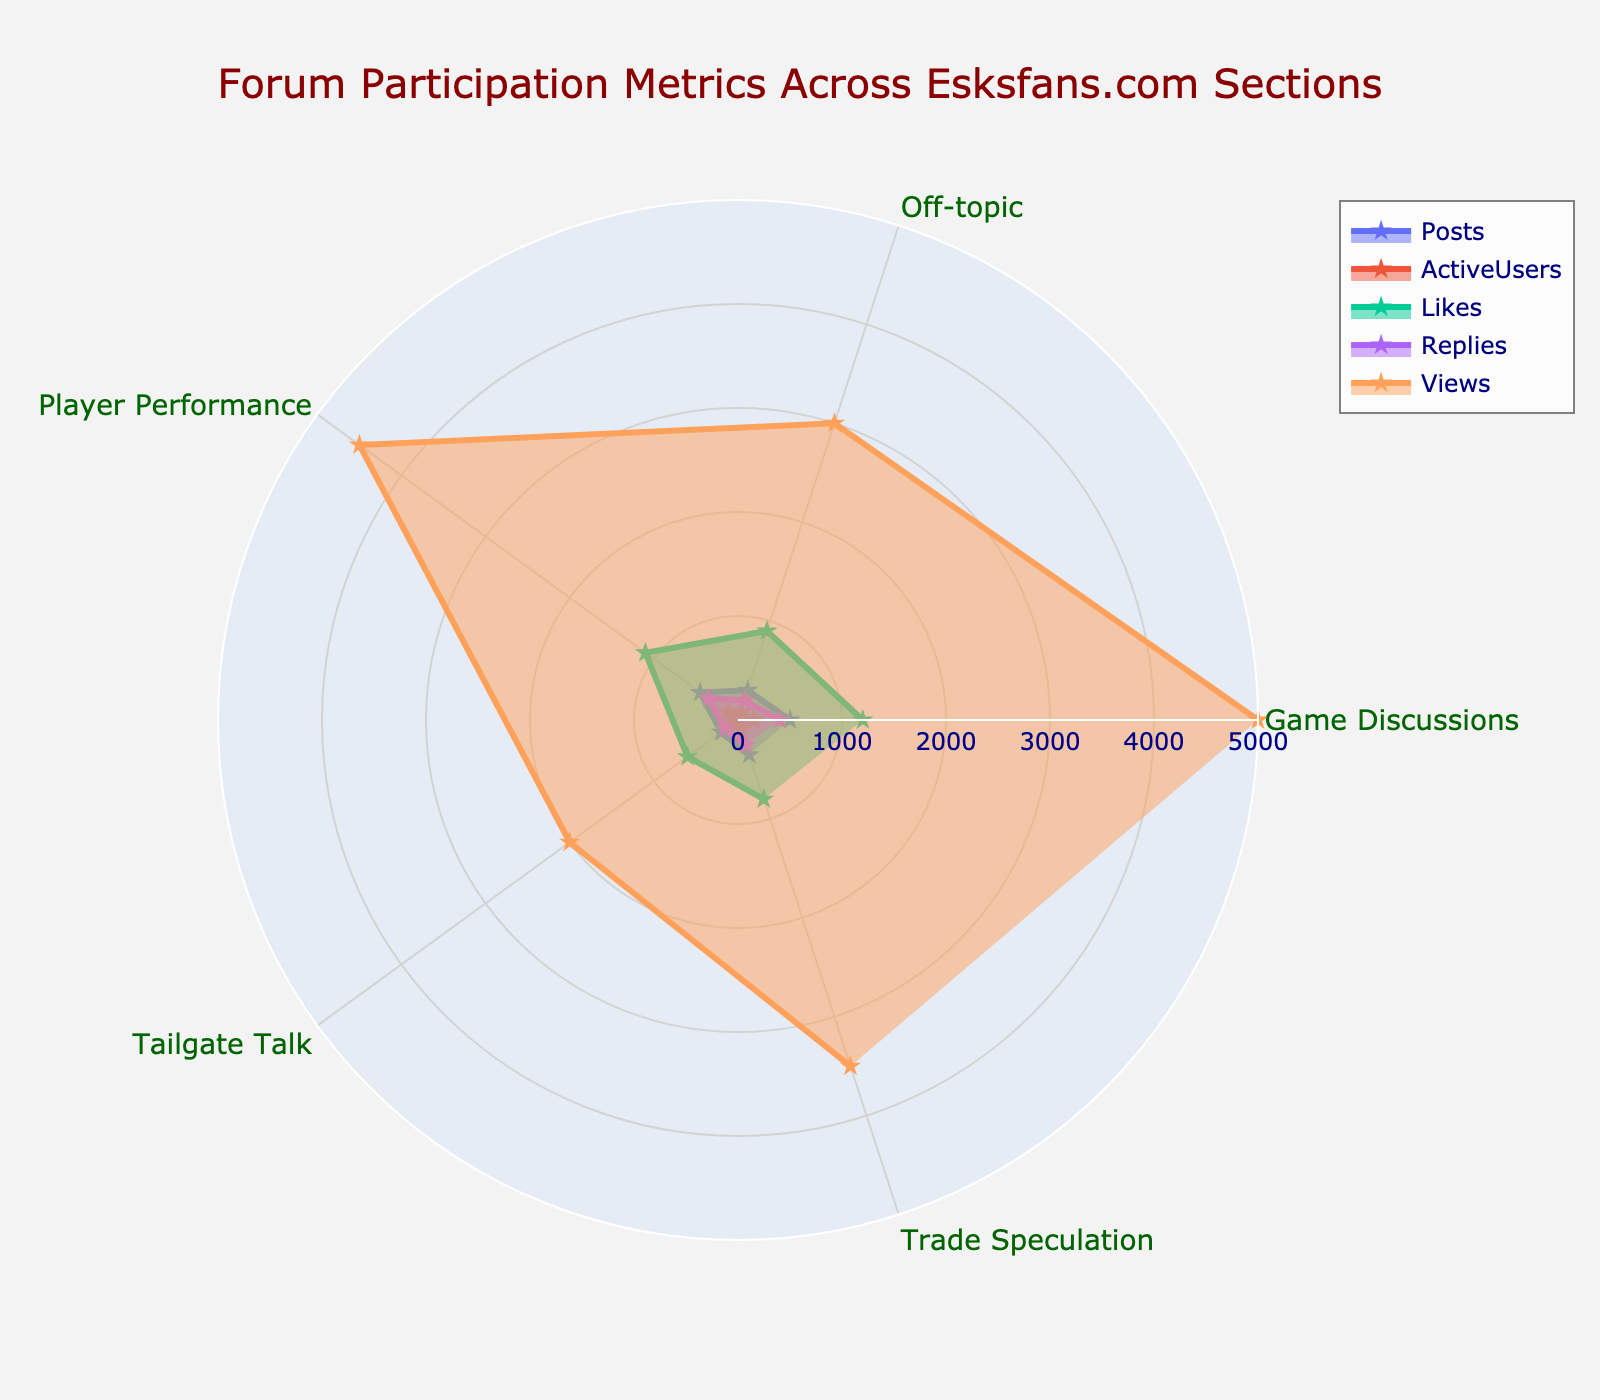what is the section with the highest number of posts?, why is this number high, and why is it important? The radar chart shows the number of posts for each section. The Game Discussions section has the highest number of posts, which indicates a high level of engagement from users who are actively discussing game-related topics. This is important because it suggests that game discussions are the most popular area, potentially driving the most traffic to the forum.
Answer: Game Discussions Which section has the least number of active users? By looking at the radar chart where each section's number of active users is plotted, Tailgate Talk shows the lowest number of active users.
Answer: Tailgate Talk Overall, which metric shows the greatest spread among the sections? To determine the greatest spread, we look for the metric with the widest variation between its minimum and maximum values across all sections. On the radar chart, the metric for Views has the greatest spread, ranging from 2000 to 5000, which illustrates that viewing activity significantly varies by section.
Answer: Views What section features the highest amount of Likes and what does this tell us about user engagement? The radar chart illustrates that Game Discussions has the highest amount of Likes. This high number of likes indicates strong user engagement and suggests that the discussions in this section are highly appreciated or found very informative by community members.
Answer: Game Discussions Compare the number of replies in Game Discussions and Player Performance. In which section is there more interaction and by how much? By comparing the radar chart data, we see that Game Discussions has 400 replies while Player Performance has 350. Therefore, Game Discussions has more interaction by 50 replies.
Answer: Game Discussions, by 50 replies Which metric is the least consistent across all sections? Based on the radar chart, the metric 'Active Users' appears to be the least consistent as it fluctuates significantly between sections, showing large differences in engagement levels.
Answer: Active Users What can be inferred from the relatively higher number of posts and views in the Trade Speculation section? The radar chart shows Trade Speculation has relatively high numbers of posts and views. This suggests that users have a strong interest in trade rumors and speculation and that this section is both visited frequently and actively participated in.
Answer: High interest and frequent activity What section shows the lowest likes considering the data, and how might this affect the perceived quality of its content? The radar chart indicates that Tailgate Talk has the lowest number of likes. This could suggest that the content in this section is less engaging or less appreciated by users, which might affect its perceived quality negatively.
Answer: Tailgate Talk 